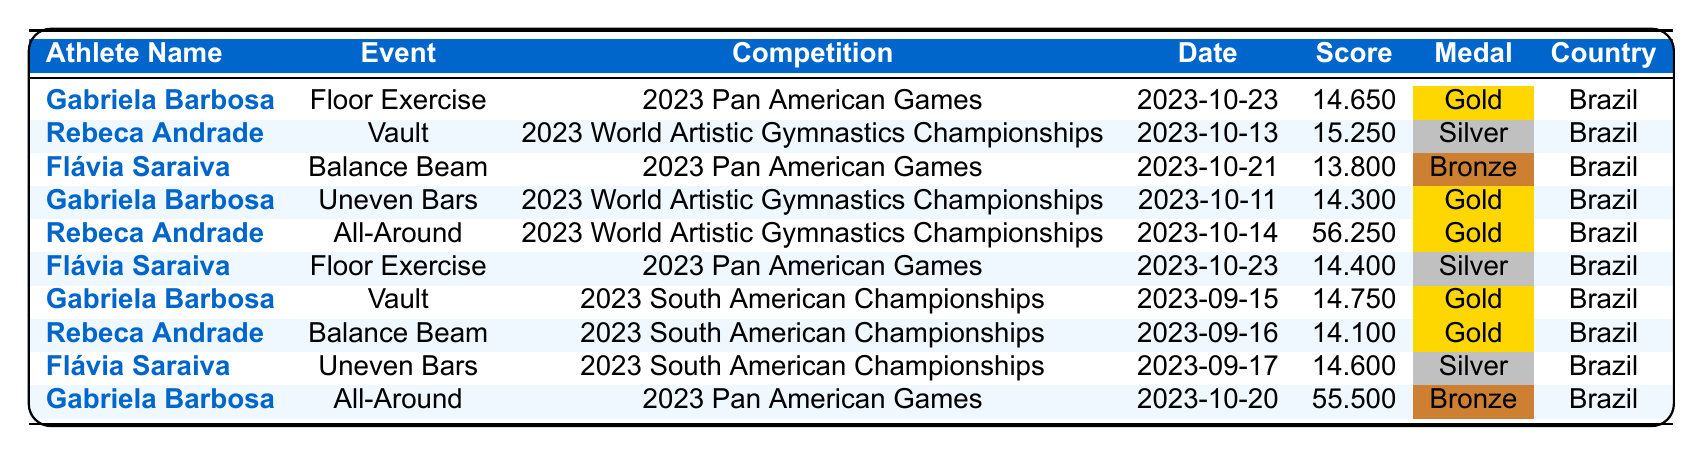What was Gabriela Barbosa's score on the Floor Exercise at the 2023 Pan American Games? According to the table, Gabriela Barbosa scored 14.650 on the Floor Exercise at the 2023 Pan American Games on 2023-10-23.
Answer: 14.650 Which athlete won a Silver medal at the 2023 World Artistic Gymnastics Championships? The table shows that Rebeca Andrade won a Silver medal on Vault at the 2023 World Artistic Gymnastics Championships on 2023-10-13.
Answer: Rebeca Andrade How many Gold medals did Flávia Saraiva win in the 2023 season? From the table, Flávia Saraiva won 1 Gold medal, which was at the 2023 South American Championships on Balance Beam.
Answer: 1 What was the highest score achieved by Rebeca Andrade? The table indicates that Rebeca Andrade scored 56.250 in the All-Around at the 2023 World Artistic Gymnastics Championships on 2023-10-14, which is her highest score.
Answer: 56.250 Did Gabriela Barbosa participate in the Uneven Bars event at both the Pan American and World Championships? The table shows that Gabriela Barbosa participated in the Uneven Bars event only at the 2023 World Artistic Gymnastics Championships and not at the Pan American Games; therefore, the answer is no.
Answer: No What is the total number of medals won by Gabriela Barbosa in the 2023 season? In the table, Gabriela Barbosa won 3 medals: 2 Gold medals (on Floor Exercise and Vault) and 1 Bronze medal (in All-Around). Therefore, the total is 3 medals.
Answer: 3 Which competition had the highest individual score recorded in the table? The highest score recorded in the table is 56.250 by Rebeca Andrade during the All-Around at the 2023 World Artistic Gymnastics Championships, making it the highest score.
Answer: 56.250 What was Flávia Saraiva's score on the Balance Beam at the 2023 Pan American Games? According to the table, Flávia Saraiva scored 13.800 on the Balance Beam at the 2023 Pan American Games on 2023-10-21.
Answer: 13.800 How many different gymnasts won Gold medals across the events listed? By reviewing the table, we find that 3 different gymnasts won Gold medals: Gabriela Barbosa (2 Golds) and Rebeca Andrade (1 Gold). Hence, the total number of different gold medalists is 2.
Answer: 2 What was the medal distribution for the Floor Exercise event at the 2023 Pan American Games? The medal distribution shows Gabriela Barbosa won Gold, Flávia Saraiva won Silver in the Floor Exercise at the 2023 Pan American Games; thus, the distribution is Gold: Gabriela, Silver: Flávia.
Answer: Gold: Gabriela, Silver: Flávia Which event had the lowest score awarded in the table? Analyzing the scores in the table, the lowest score is 13.800 by Flávia Saraiva on the Balance Beam at the 2023 Pan American Games, so this is the event with the lowest score.
Answer: 13.800 